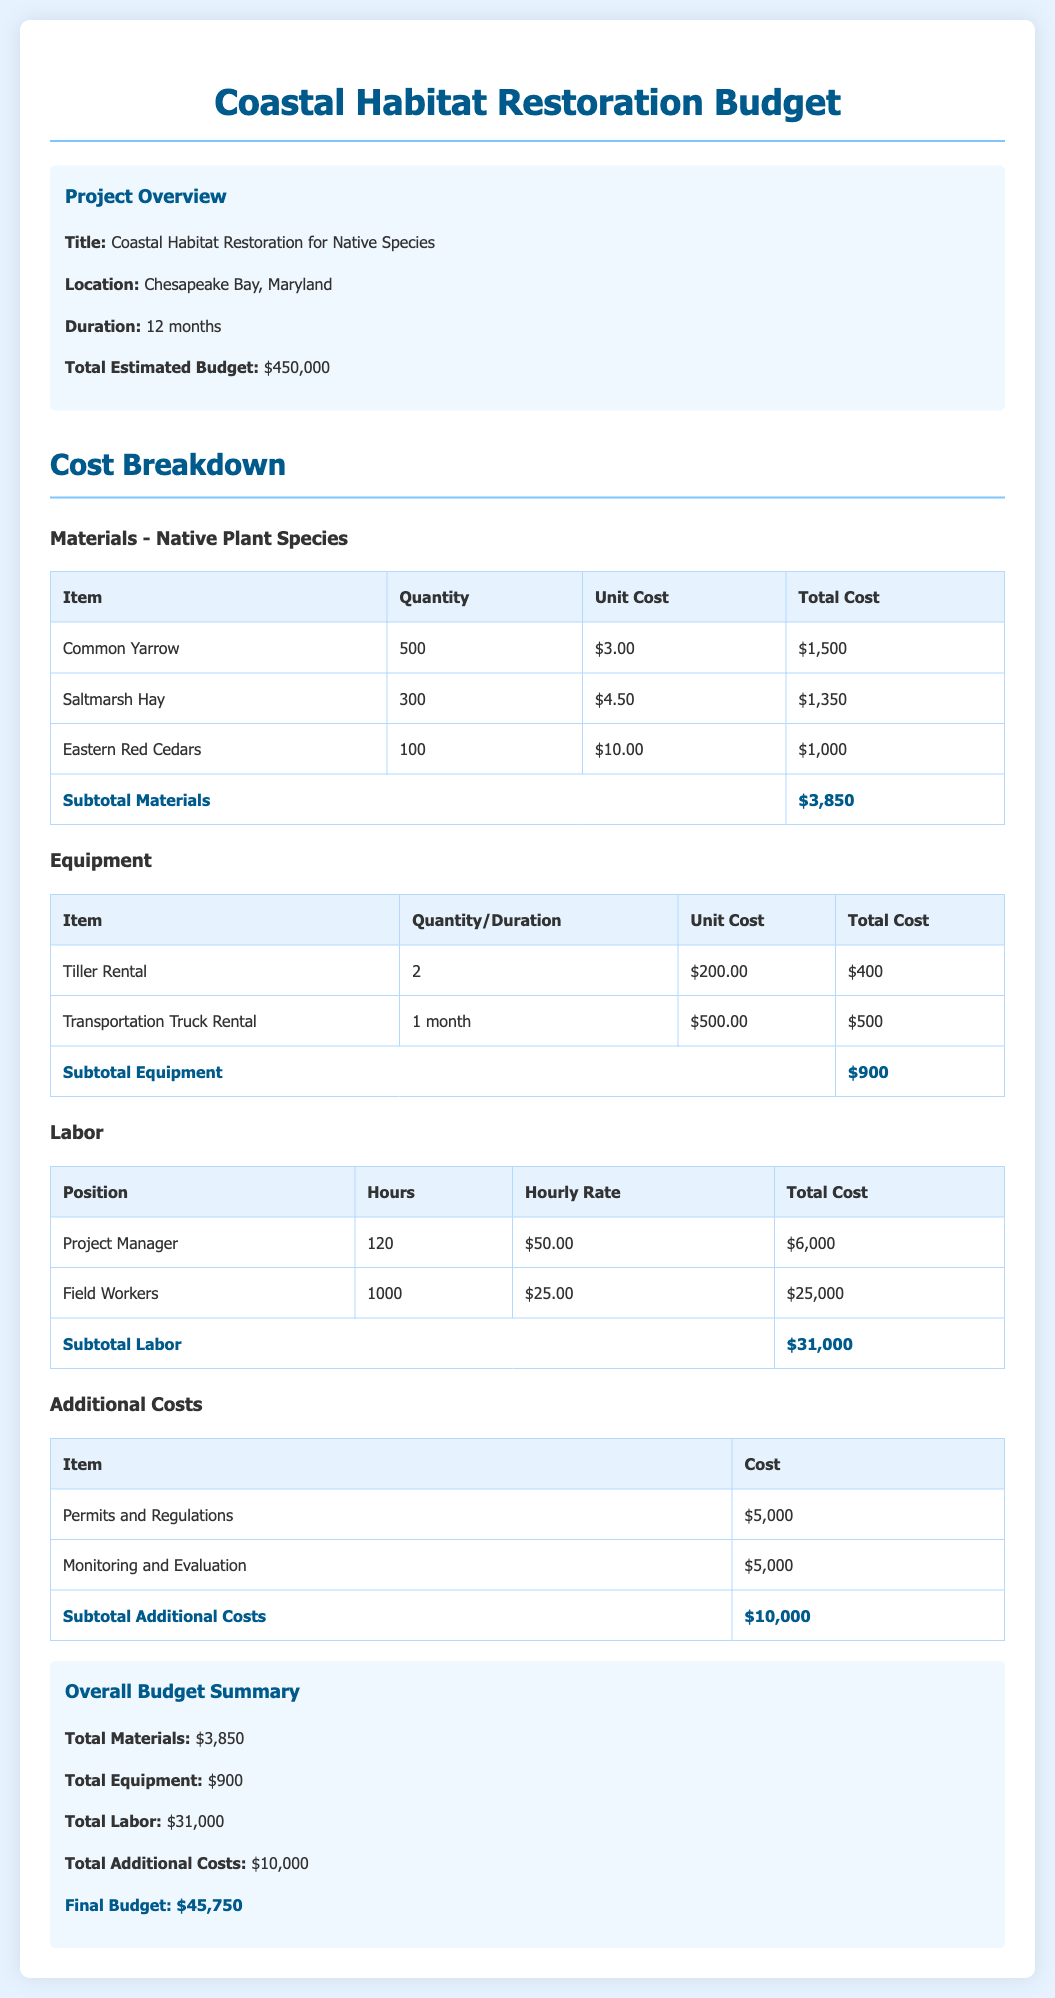What is the total estimated budget? The total estimated budget is stated in the summary section of the document.
Answer: $450,000 What is the location of the project? The location of the project is provided in the project overview section.
Answer: Chesapeake Bay, Maryland How many hours are allocated for the Project Manager? The hours for the Project Manager can be found in the labor section of the document.
Answer: 120 What is the unit cost of Saltmarsh Hay? The unit cost of Saltmarsh Hay can be retrieved from the materials table.
Answer: $4.50 What are the total additional costs? The total additional costs are summarized in the overall budget summary section.
Answer: $10,000 How much will the Field Workers be paid in total? The total cost for Field Workers is detailed in the labor section.
Answer: $25,000 What is the total labor cost? The total labor cost is provided in the summary for the labor section.
Answer: $31,000 What is the total cost for equipment? The total cost for equipment is available in the equipment subtotal section.
Answer: $900 What is the quantity of Common Yarrow? The quantity of Common Yarrow is specified in the materials table.
Answer: 500 